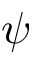Convert formula to latex. <formula><loc_0><loc_0><loc_500><loc_500>\psi</formula> 